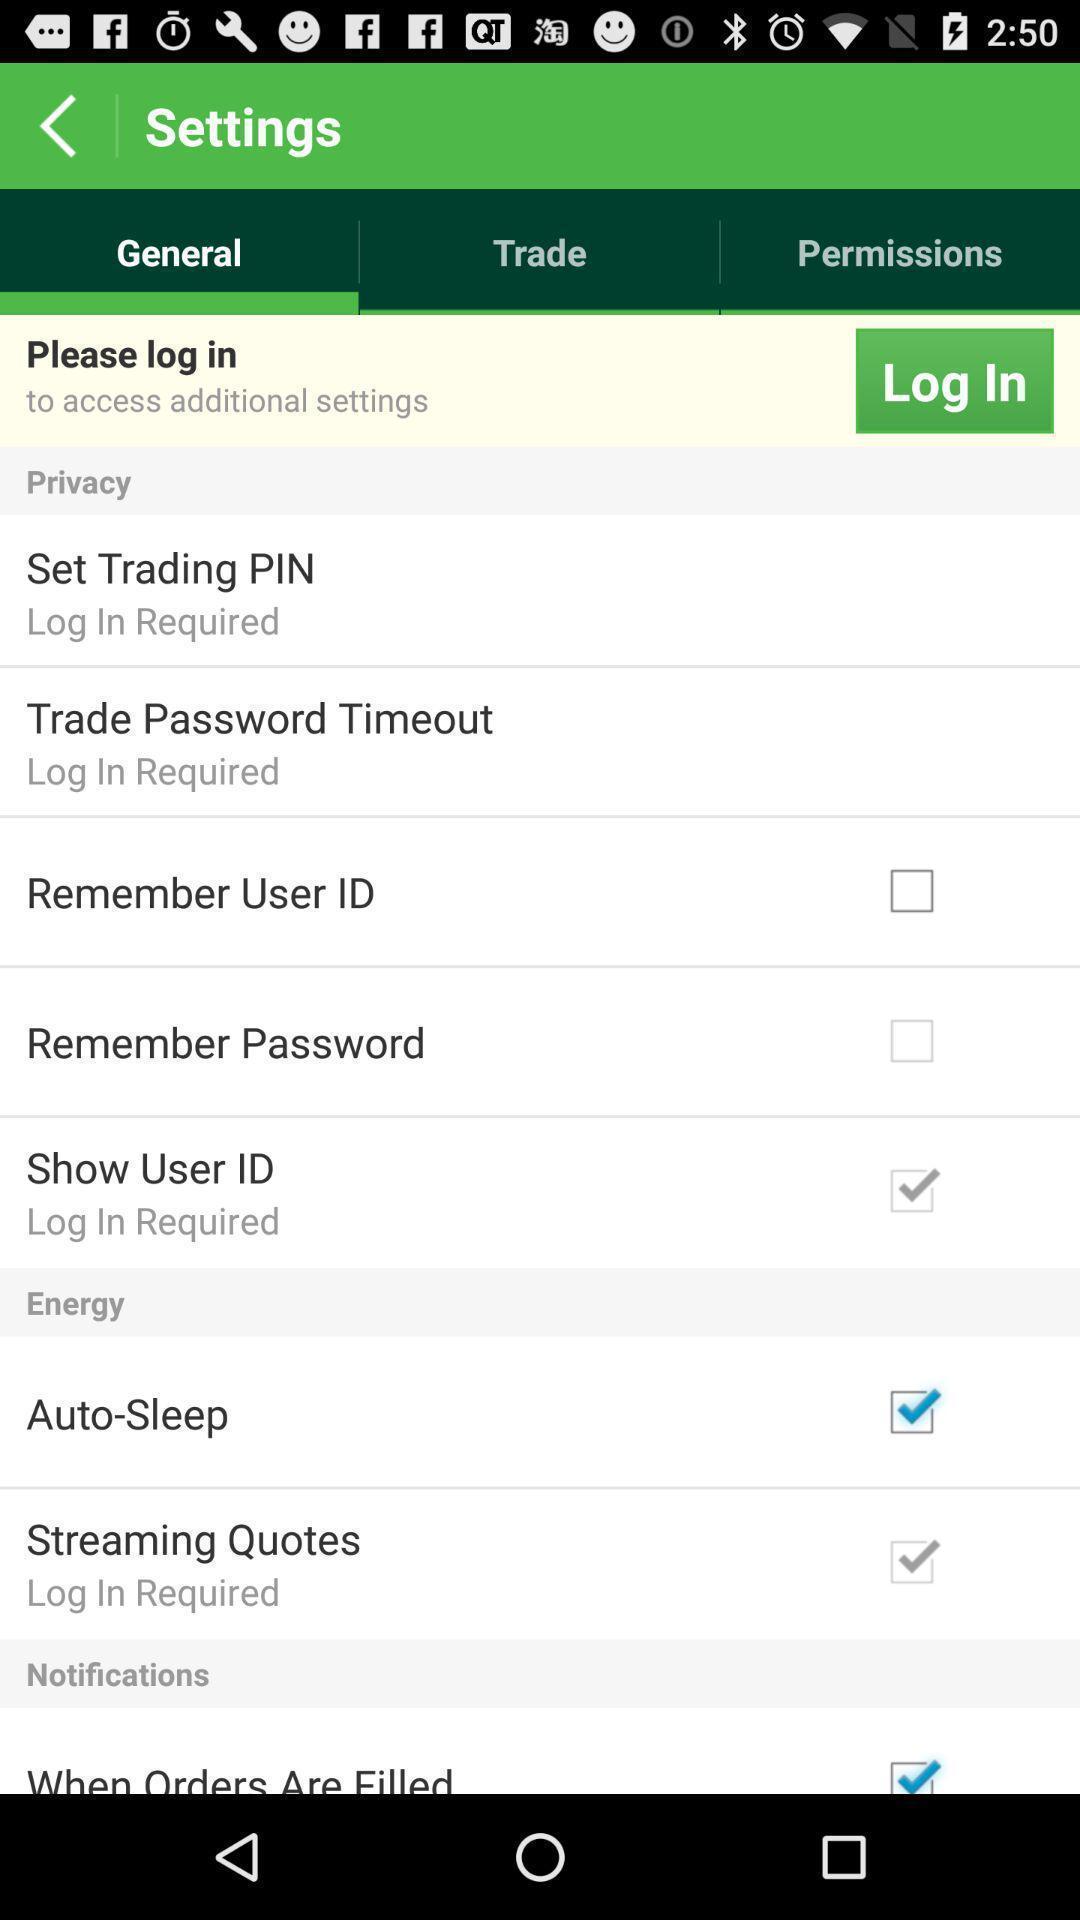What is the overall content of this screenshot? Page showing the options in settings. 